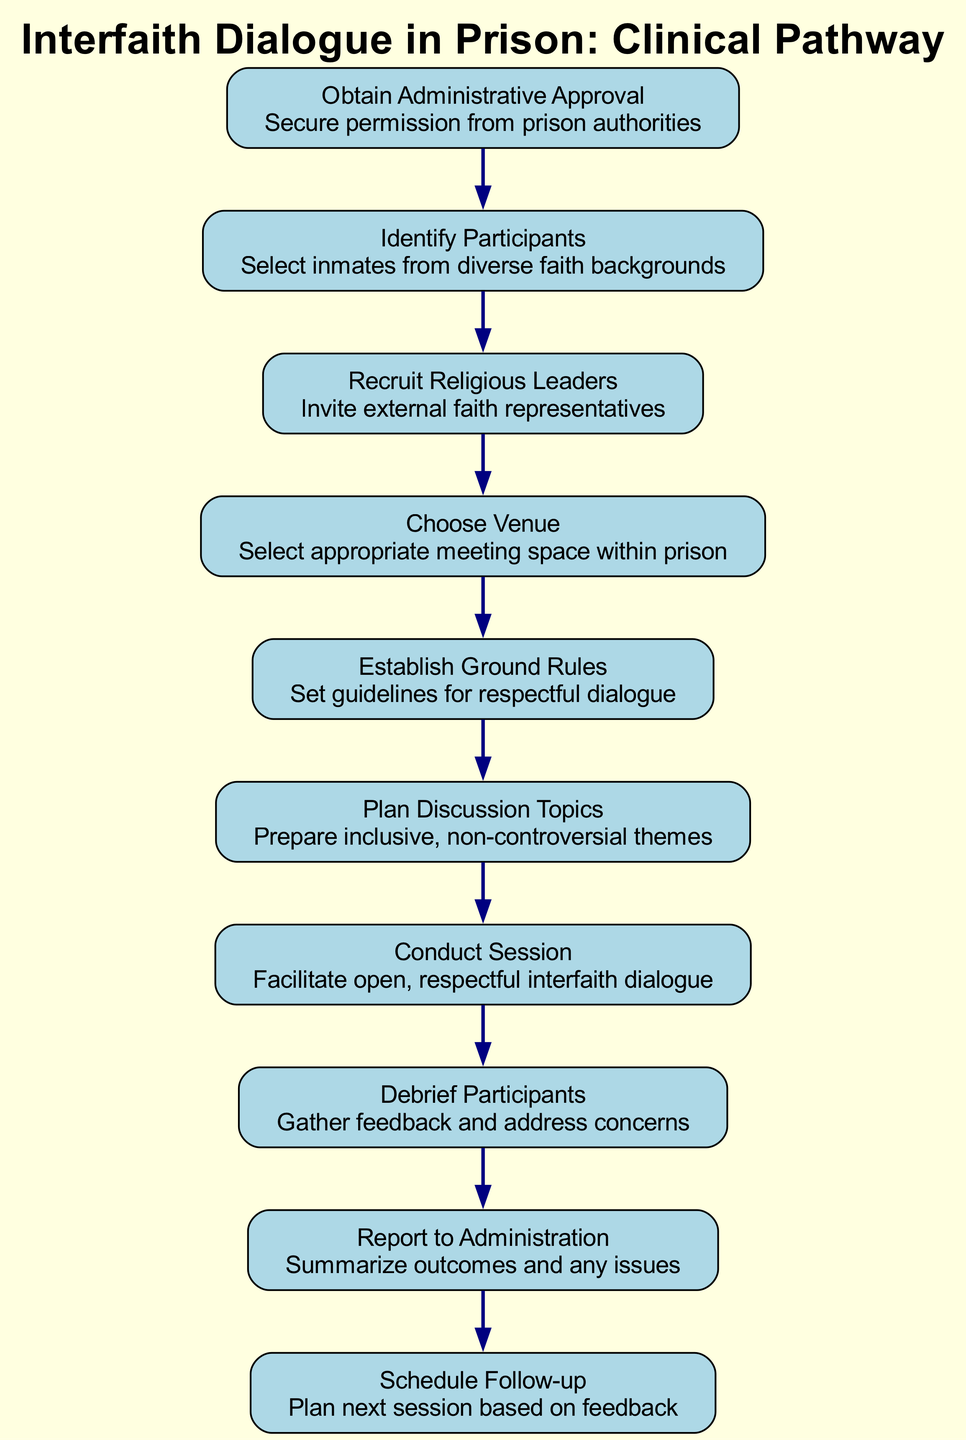What is the first step in the clinical pathway? The first step listed in the diagram is "Obtain Administrative Approval." This can be found at the top of the pathway, serving as the starting point.
Answer: Obtain Administrative Approval How many steps are involved in this clinical pathway? By counting the steps presented in the diagram, there are a total of 10 distinct steps in the process.
Answer: 10 Which step follows "Choose Venue"? The step that directly follows "Choose Venue" in the flow of the diagram is "Establish Ground Rules." By looking at the progression from one node to the next, this is the immediate next action.
Answer: Establish Ground Rules What is the final step in the clinical pathway? The last step listed in the pathway is "Schedule Follow-up," which appears at the bottom of the flow. It's the concluding action aimed at future sessions.
Answer: Schedule Follow-up What is the relationship between "Conduct Session" and "Debrief Participants"? "Conduct Session" leads directly to "Debrief Participants," indicating that after the dialogue session occurs, the next action is to solicit feedback from participants. This shows a clear sequential relationship between these two actions.
Answer: Conduct Session → Debrief Participants What is established in the "Establish Ground Rules" step? This step focuses on setting guidelines for respectful dialogue, ensuring that the participants understand the importance of maintaining civility and respect during discussions.
Answer: Guidelines for respectful dialogue Which step involves inviting external faith representatives? The step that includes this action is "Recruit Religious Leaders". It specifies the need to bring in external individuals to facilitate dialogue among diverse faiths.
Answer: Recruit Religious Leaders What should be done based on feedback gathered from participants? The next action following the "Debrief Participants" step is "Schedule Follow-up," emphasizing the need to plan future sessions according to participant feedback.
Answer: Schedule Follow-up What type of topics should be planned for discussion? The "Plan Discussion Topics" step mentions the necessity to prepare inclusive and non-controversial themes, highlighting the intent to foster a collaborative and peaceful dialogue environment.
Answer: Inclusive, non-controversial themes 